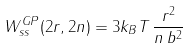<formula> <loc_0><loc_0><loc_500><loc_500>W ^ { G P } _ { s s } ( 2 r , 2 n ) = 3 k _ { B } T \, \frac { r ^ { 2 } } { n \, b ^ { 2 } }</formula> 